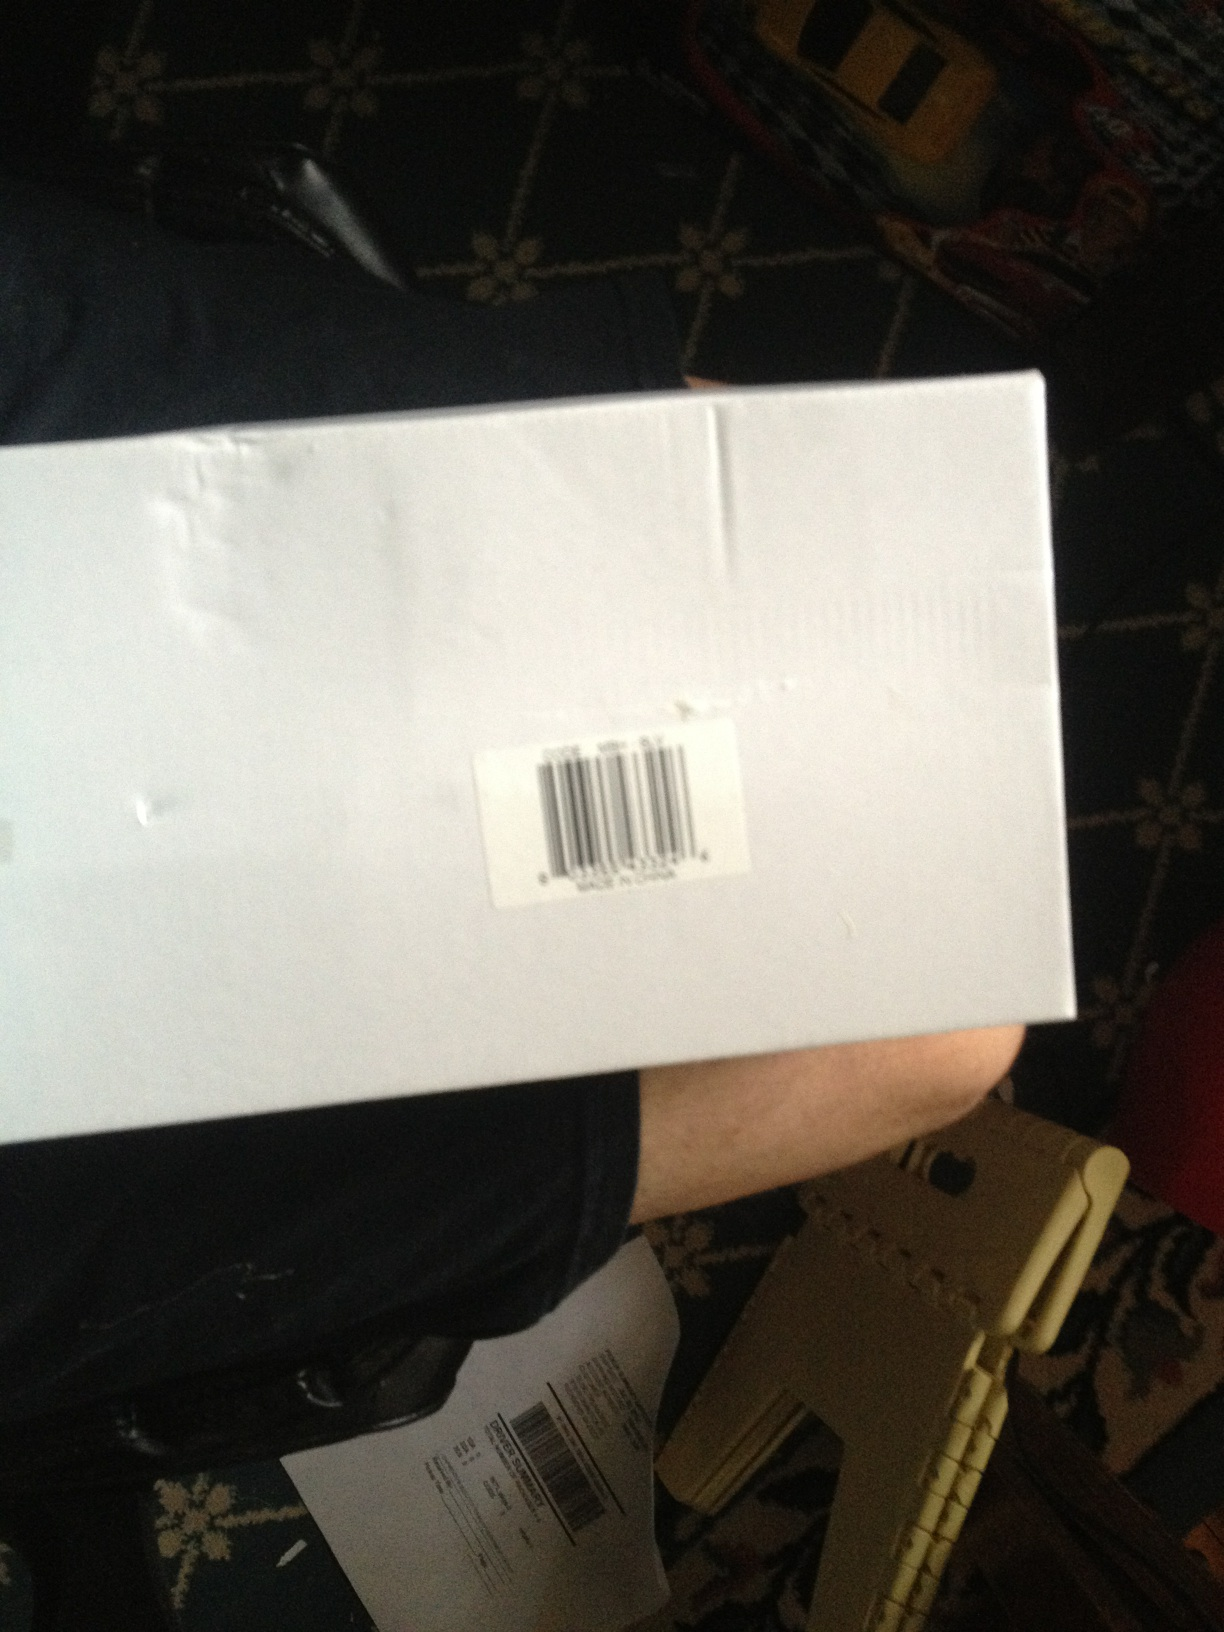Write a short story involving this box in a magical adventure. Once upon a time, a humble white box sat idly on a shelf in an old, dusty attic. One day, a young girl named Lucy discovered it. To her astonishment, the moment she touched the box, it glowed softly and grew warm. Inside, she found a map and a small, intricately designed key. The map revealed hidden locations that led to enchanted lands unknown to the ordinary world. With the key, Lucy unlocked a magical portal that transported her to a realm filled with mystical creatures and endless adventures. Each treasure she uncovered in this new world was safely sent back through her magical box, bridging the gap between two worlds. Lucy's life became a tapestry of extraordinary tales, all starting from that simple, unassuming white box. 